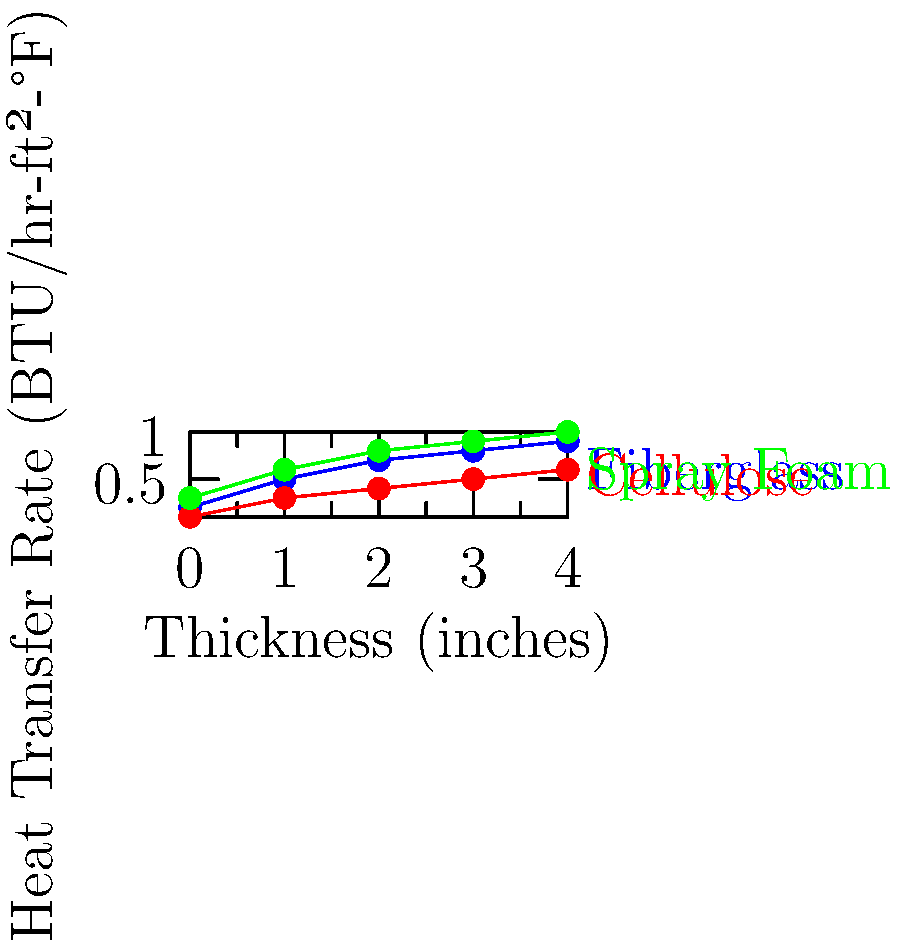As a home-front volunteer assisting military families, you're advising on energy-efficient home improvements. Based on the graph showing heat transfer rates for different insulation materials, which insulation type would you recommend for maximizing energy efficiency in a home, and why? To determine the most energy-efficient insulation material, we need to analyze the heat transfer rates shown in the graph:

1. Identify the materials:
   - Blue line: Fiberglass
   - Red line: Cellulose
   - Green line: Spray Foam

2. Compare heat transfer rates:
   - Lower heat transfer rates indicate better insulation properties.
   - At all thicknesses, cellulose (red line) shows the lowest heat transfer rate.

3. Consider thickness:
   - As thickness increases, heat transfer rates decrease for all materials.
   - Cellulose maintains the lowest rate across all thicknesses.

4. Energy efficiency:
   - Lower heat transfer rates mean less heat loss in winter and less heat gain in summer.
   - This translates to lower energy consumption for heating and cooling.

5. Cost-effectiveness:
   - While not shown in the graph, cellulose is generally more affordable than spray foam.
   - It performs better than fiberglass, which is also commonly used.

6. Environmental impact:
   - Cellulose is often made from recycled materials, making it an eco-friendly choice.

7. Installation considerations:
   - Cellulose can be easily added to existing walls without major renovations.
   - This is beneficial for retrofitting homes of deployed servicemembers.

Based on these factors, cellulose insulation would be the most recommended option for maximizing energy efficiency in a home. It consistently shows the lowest heat transfer rate, is cost-effective, and environmentally friendly.
Answer: Cellulose insulation, due to its lowest heat transfer rate across all thicknesses. 